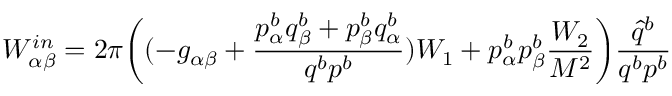<formula> <loc_0><loc_0><loc_500><loc_500>W _ { \alpha \beta } ^ { i n } = 2 \pi \left ( ( - g _ { \alpha \beta } + { \frac { p _ { \alpha } ^ { b } q _ { \beta } ^ { b } + p _ { \beta } ^ { b } q _ { \alpha } ^ { b } } { q ^ { b } p ^ { b } } } ) W _ { 1 } + p _ { \alpha } ^ { b } p _ { \beta } ^ { b } { \frac { W _ { 2 } } { M ^ { 2 } } } \right ) { \frac { \hat { q } ^ { b } } { q ^ { b } p ^ { b } } }</formula> 